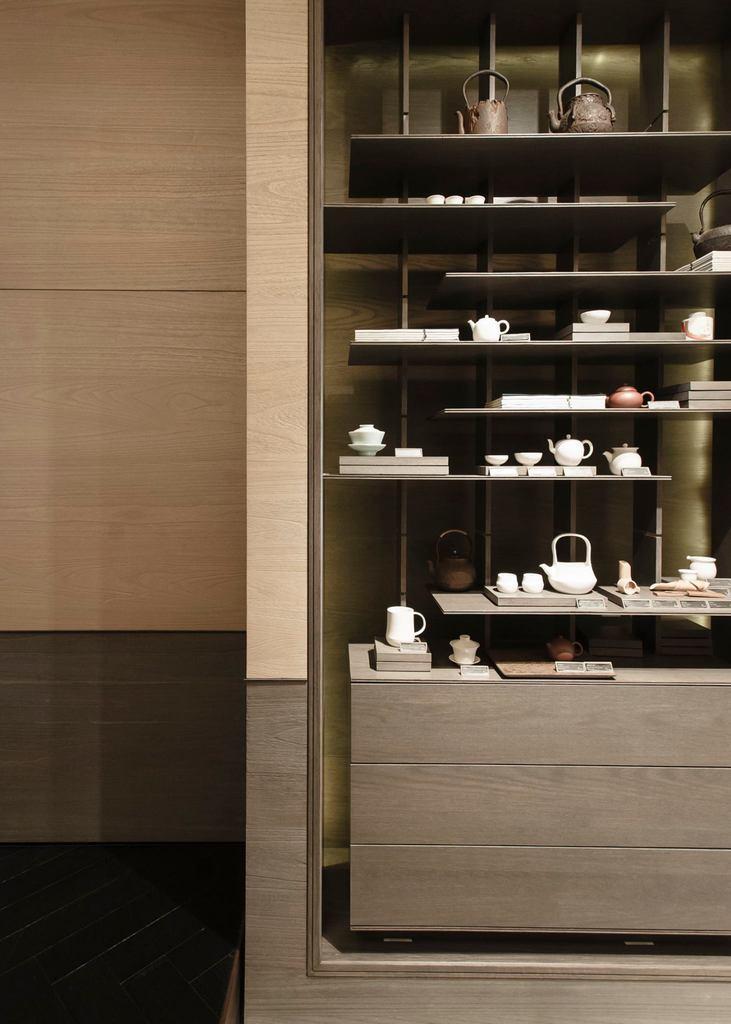Please provide a concise description of this image. In this image there is a rack and we can see teapot, cups, books and some objects placed in the rack. In the background there is a wall. 